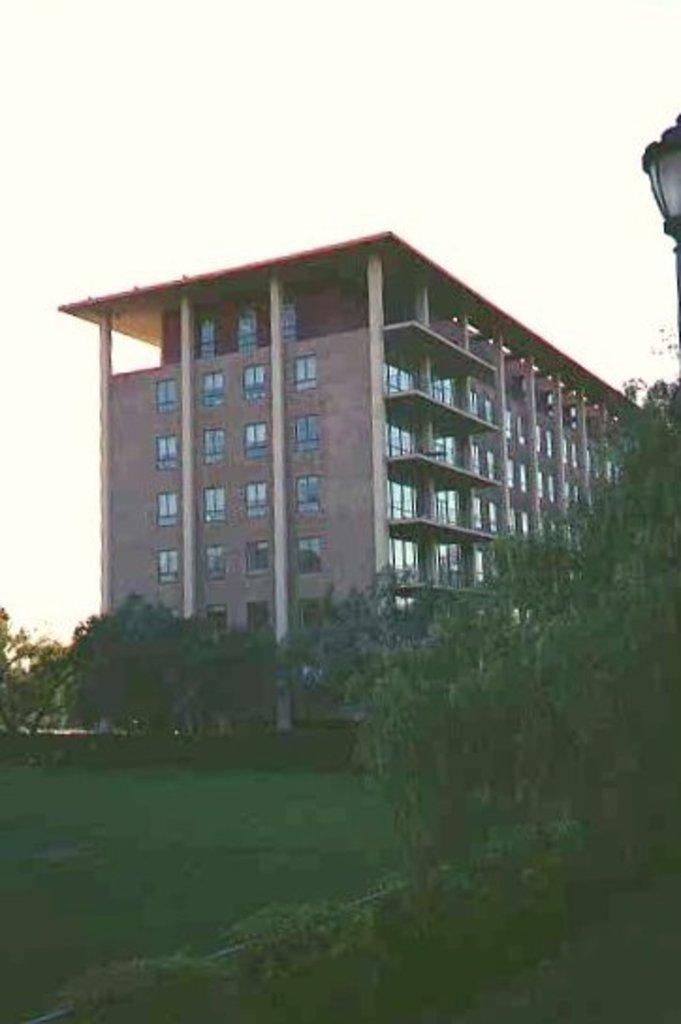What type of vegetation is present in the image? There is grass and trees in the image. Can you describe the lighting in the image? There is a light on the right side of the image. What type of structure can be seen in the background of the image? There is a building with windows in the background of the image. What type of pickle is hanging from the tree in the image? There is no pickle present in the image; it features grass, trees, a light, and a building in the background. Can you tell me how many fans are visible in the image? There are no fans present in the image. 